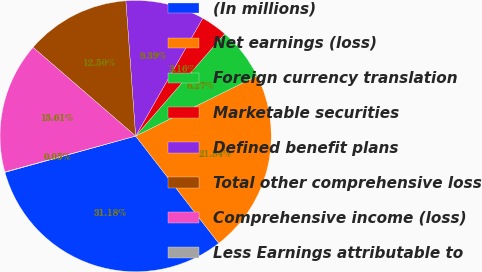<chart> <loc_0><loc_0><loc_500><loc_500><pie_chart><fcel>(In millions)<fcel>Net earnings (loss)<fcel>Foreign currency translation<fcel>Marketable securities<fcel>Defined benefit plans<fcel>Total other comprehensive loss<fcel>Comprehensive income (loss)<fcel>Less Earnings attributable to<nl><fcel>31.18%<fcel>21.84%<fcel>6.27%<fcel>3.16%<fcel>9.39%<fcel>12.5%<fcel>15.61%<fcel>0.05%<nl></chart> 